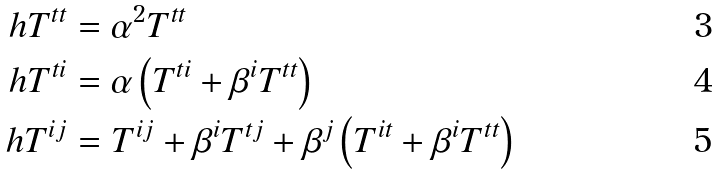<formula> <loc_0><loc_0><loc_500><loc_500>\ h { T } ^ { t t } & = \alpha ^ { 2 } T ^ { t t } \\ \ h { T } ^ { t i } & = \alpha \left ( T ^ { t i } + \beta ^ { i } T ^ { t t } \right ) \\ \ h { T } ^ { i j } & = T ^ { i j } + \beta ^ { i } T ^ { t j } + \beta ^ { j } \left ( T ^ { i t } + \beta ^ { i } T ^ { t t } \right )</formula> 